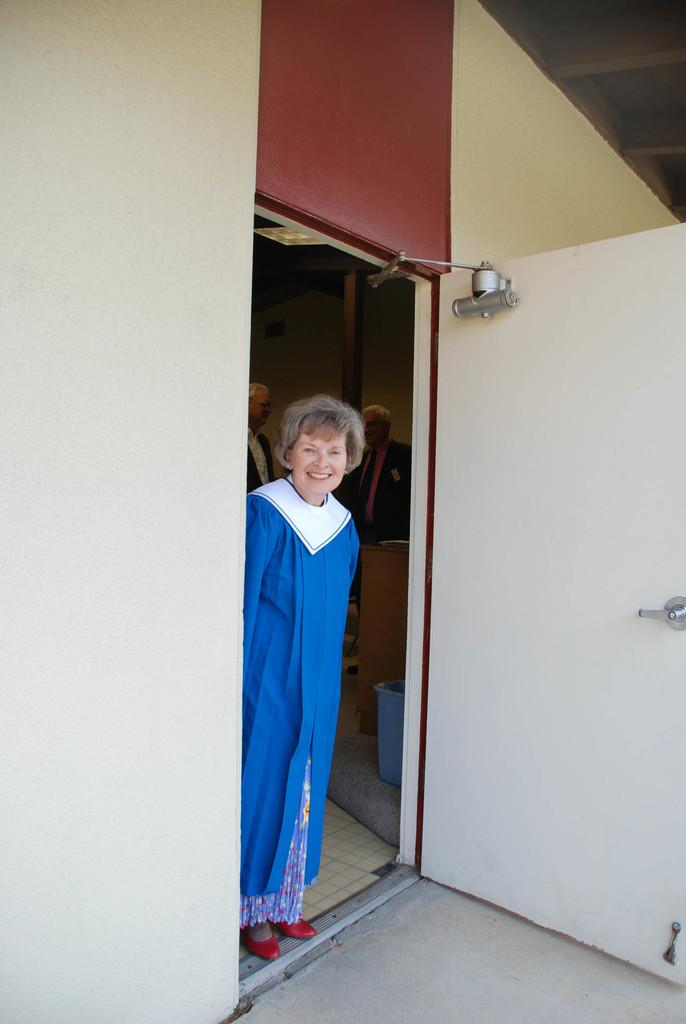What is the person in the image wearing? The person is wearing a blue and white color dress in the image. How many people are present in the image? There are people in the image. What color is the bucket visible in the image? There is a blue color bucket in the image. What type of structure can be seen in the image? There is a building in the image. What feature of the building is visible in the image? There is a door in the image. Where is the playground located in the image? There is no playground present in the image. What type of nation is depicted in the image? The image does not depict a nation; it shows a person, people, a bucket, a building, and a door. 